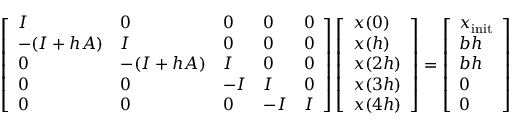Convert formula to latex. <formula><loc_0><loc_0><loc_500><loc_500>\left [ \begin{array} { l l l l l } { I } & { 0 } & { 0 } & { 0 } & { 0 } \\ { - ( I + h A ) } & { I } & { 0 } & { 0 } & { 0 } \\ { 0 } & { - ( I + h A ) } & { I } & { 0 } & { 0 } \\ { 0 } & { 0 } & { - I } & { I } & { 0 } \\ { 0 } & { 0 } & { 0 } & { - I } & { I } \end{array} \right ] \left [ \begin{array} { l } { x ( 0 ) } \\ { x ( h ) } \\ { x ( 2 h ) } \\ { x ( 3 h ) } \\ { x ( 4 h ) } \end{array} \right ] = \left [ \begin{array} { l } { x _ { i n i t } } \\ { b h } \\ { b h } \\ { 0 } \\ { 0 } \end{array} \right ]</formula> 